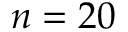<formula> <loc_0><loc_0><loc_500><loc_500>n = 2 0</formula> 